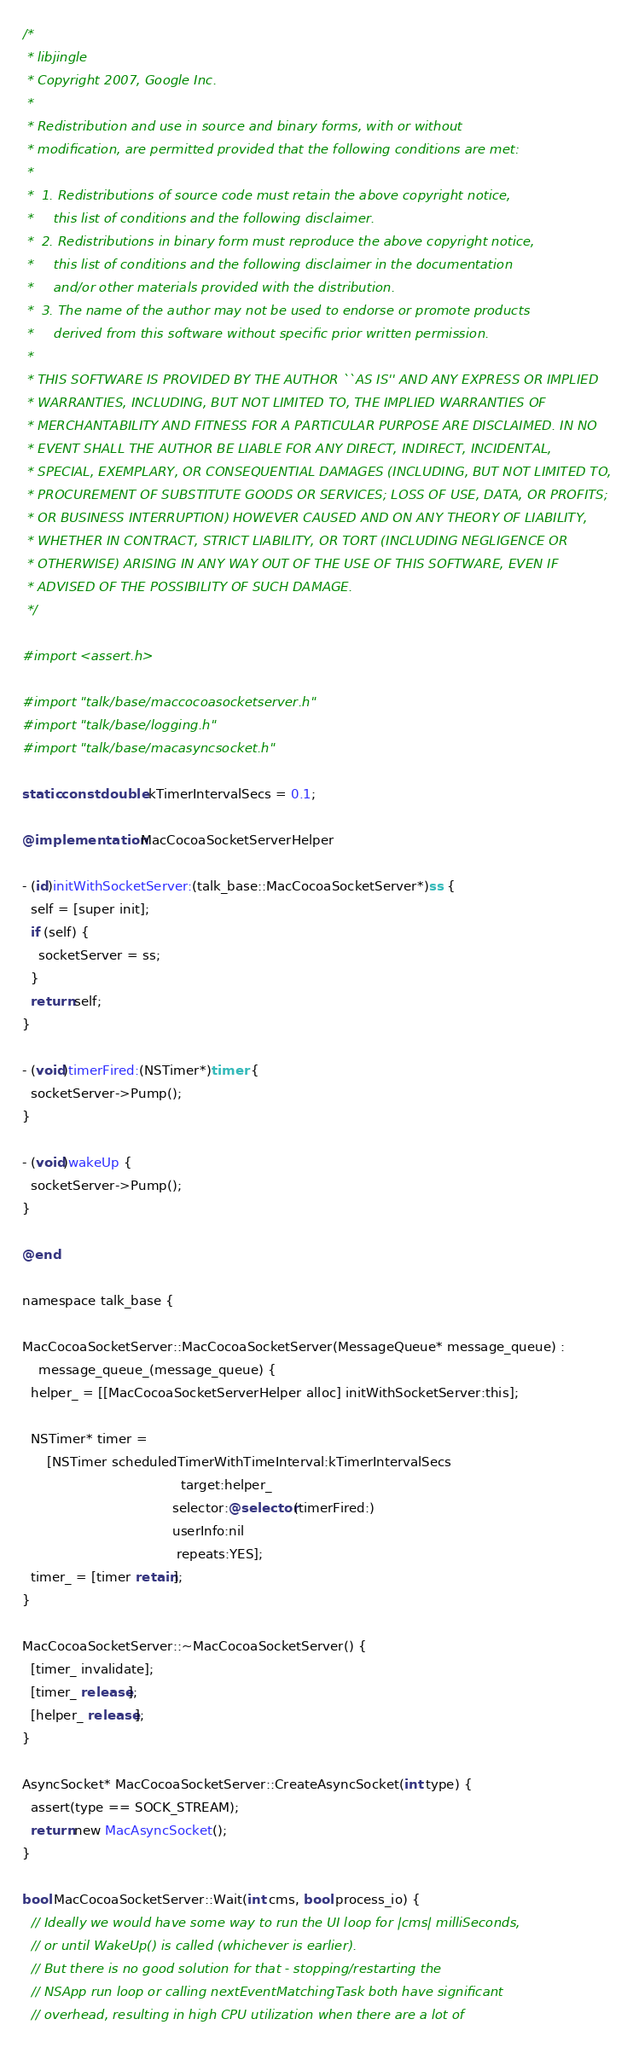Convert code to text. <code><loc_0><loc_0><loc_500><loc_500><_ObjectiveC_>/*
 * libjingle
 * Copyright 2007, Google Inc.
 *
 * Redistribution and use in source and binary forms, with or without
 * modification, are permitted provided that the following conditions are met:
 *
 *  1. Redistributions of source code must retain the above copyright notice,
 *     this list of conditions and the following disclaimer.
 *  2. Redistributions in binary form must reproduce the above copyright notice,
 *     this list of conditions and the following disclaimer in the documentation
 *     and/or other materials provided with the distribution.
 *  3. The name of the author may not be used to endorse or promote products
 *     derived from this software without specific prior written permission.
 *
 * THIS SOFTWARE IS PROVIDED BY THE AUTHOR ``AS IS'' AND ANY EXPRESS OR IMPLIED
 * WARRANTIES, INCLUDING, BUT NOT LIMITED TO, THE IMPLIED WARRANTIES OF
 * MERCHANTABILITY AND FITNESS FOR A PARTICULAR PURPOSE ARE DISCLAIMED. IN NO
 * EVENT SHALL THE AUTHOR BE LIABLE FOR ANY DIRECT, INDIRECT, INCIDENTAL,
 * SPECIAL, EXEMPLARY, OR CONSEQUENTIAL DAMAGES (INCLUDING, BUT NOT LIMITED TO,
 * PROCUREMENT OF SUBSTITUTE GOODS OR SERVICES; LOSS OF USE, DATA, OR PROFITS;
 * OR BUSINESS INTERRUPTION) HOWEVER CAUSED AND ON ANY THEORY OF LIABILITY,
 * WHETHER IN CONTRACT, STRICT LIABILITY, OR TORT (INCLUDING NEGLIGENCE OR
 * OTHERWISE) ARISING IN ANY WAY OUT OF THE USE OF THIS SOFTWARE, EVEN IF
 * ADVISED OF THE POSSIBILITY OF SUCH DAMAGE.
 */

#import <assert.h>

#import "talk/base/maccocoasocketserver.h"
#import "talk/base/logging.h"
#import "talk/base/macasyncsocket.h"

static const double kTimerIntervalSecs = 0.1;

@implementation MacCocoaSocketServerHelper

- (id)initWithSocketServer:(talk_base::MacCocoaSocketServer*)ss {
  self = [super init];
  if (self) {
    socketServer = ss;
  }
  return self;
}

- (void)timerFired:(NSTimer*)timer {
  socketServer->Pump();
}

- (void)wakeUp {
  socketServer->Pump();
}

@end

namespace talk_base {

MacCocoaSocketServer::MacCocoaSocketServer(MessageQueue* message_queue) :
    message_queue_(message_queue) {
  helper_ = [[MacCocoaSocketServerHelper alloc] initWithSocketServer:this];

  NSTimer* timer =
      [NSTimer scheduledTimerWithTimeInterval:kTimerIntervalSecs
                                       target:helper_
                                     selector:@selector(timerFired:)
                                     userInfo:nil
                                      repeats:YES];
  timer_ = [timer retain];
}

MacCocoaSocketServer::~MacCocoaSocketServer() {
  [timer_ invalidate];
  [timer_ release];
  [helper_ release];
}

AsyncSocket* MacCocoaSocketServer::CreateAsyncSocket(int type) {
  assert(type == SOCK_STREAM);
  return new MacAsyncSocket();
}

bool MacCocoaSocketServer::Wait(int cms, bool process_io) {
  // Ideally we would have some way to run the UI loop for |cms| milliSeconds,
  // or until WakeUp() is called (whichever is earlier).
  // But there is no good solution for that - stopping/restarting the
  // NSApp run loop or calling nextEventMatchingTask both have significant
  // overhead, resulting in high CPU utilization when there are a lot of</code> 